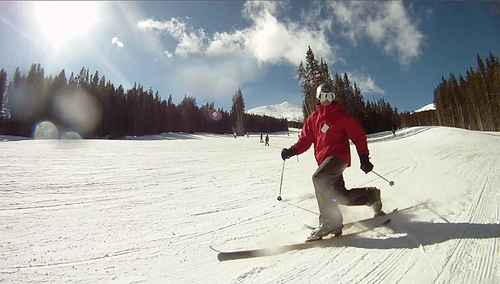Considering the attire and the gear, is this skier likely to be a beginner or more experienced? Judging by the confident posture and the parallel positioning of the skis, this skier seems to have at least an intermediate skill level. The skier is also well-equipped with a helmet for safety, goggles for eye protection, and appropriate ski attire, suggesting preparation and experience with the sport. 